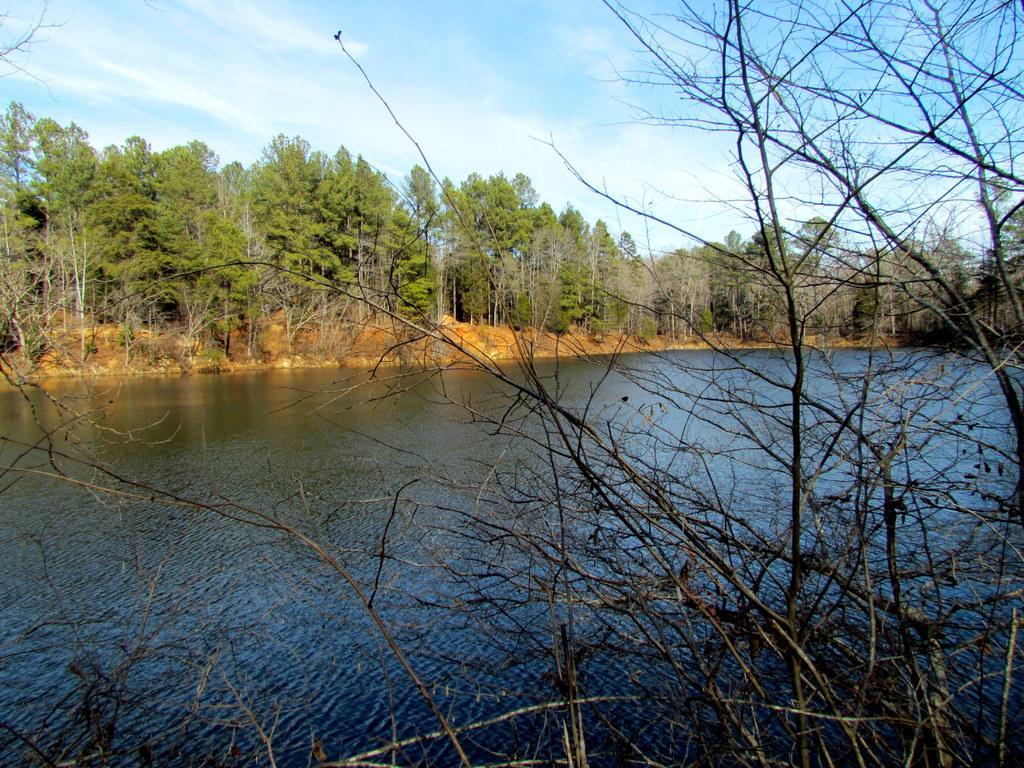In one or two sentences, can you explain what this image depicts? In this image, there is an outside view. There are some trees beside the lake. There are branches on the right side of the image. There is a sky at the top of the image. 